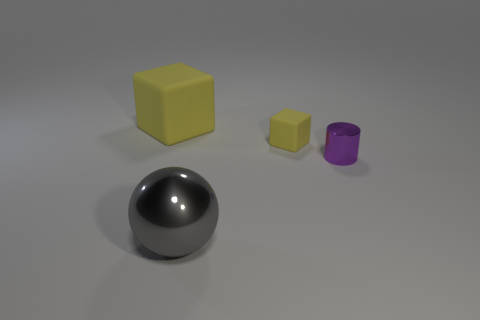What is the material of the tiny yellow block?
Ensure brevity in your answer.  Rubber. There is a metallic thing that is right of the big sphere; is its shape the same as the large shiny object?
Offer a very short reply. No. How many things are small purple metal cylinders or big cubes?
Provide a succinct answer. 2. Are the small object behind the small purple object and the large block made of the same material?
Your answer should be very brief. Yes. The ball is what size?
Make the answer very short. Large. What is the shape of the small rubber object that is the same color as the large rubber object?
Give a very brief answer. Cube. What number of blocks are either large red things or small yellow things?
Offer a very short reply. 1. Are there the same number of large yellow matte things in front of the tiny purple cylinder and big objects on the left side of the large gray metallic object?
Make the answer very short. No. There is another thing that is the same shape as the tiny yellow rubber thing; what is its size?
Offer a terse response. Large. How big is the object that is both in front of the small matte object and behind the big shiny thing?
Offer a terse response. Small. 